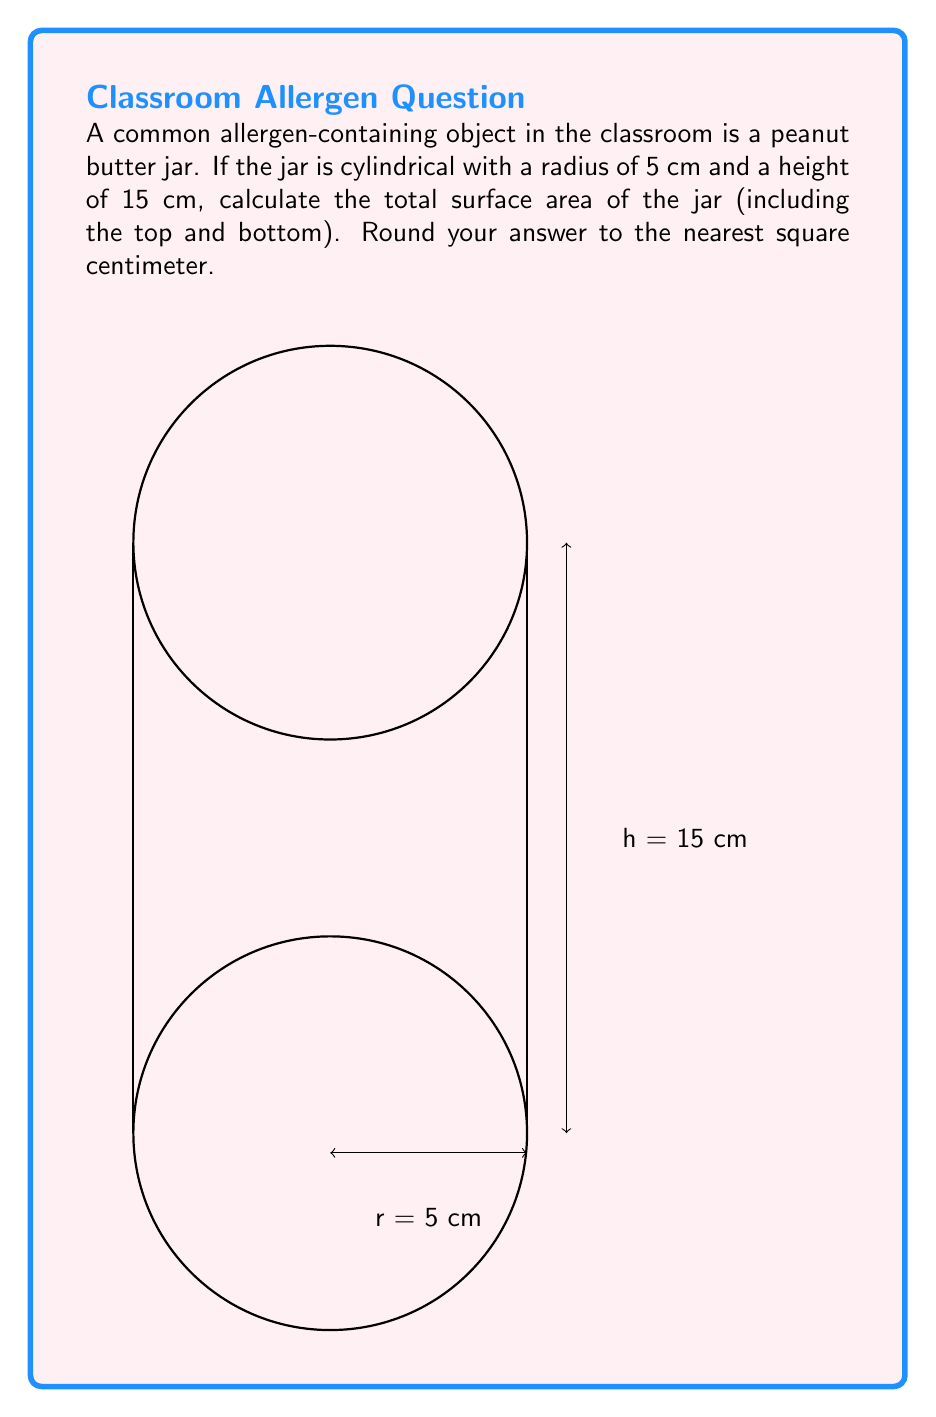Provide a solution to this math problem. To calculate the total surface area of a cylindrical jar, we need to consider three parts:
1. The circular top
2. The circular bottom
3. The curved lateral surface

Let's break it down step-by-step:

1. Area of the circular top and bottom:
   $$A_{circle} = \pi r^2$$
   $$A_{circle} = \pi (5\text{ cm})^2 = 25\pi \text{ cm}^2$$
   We have two circular surfaces, so: $2 \times 25\pi \text{ cm}^2 = 50\pi \text{ cm}^2$

2. Area of the curved lateral surface:
   $$A_{lateral} = 2\pi rh$$
   $$A_{lateral} = 2\pi (5\text{ cm})(15\text{ cm}) = 150\pi \text{ cm}^2$$

3. Total surface area:
   $$A_{total} = 2A_{circle} + A_{lateral}$$
   $$A_{total} = 50\pi \text{ cm}^2 + 150\pi \text{ cm}^2 = 200\pi \text{ cm}^2$$

4. Converting to a numerical value and rounding:
   $$A_{total} \approx 200 \times 3.14159 \approx 628.32 \text{ cm}^2$$

Rounding to the nearest square centimeter: 628 cm²
Answer: 628 cm² 